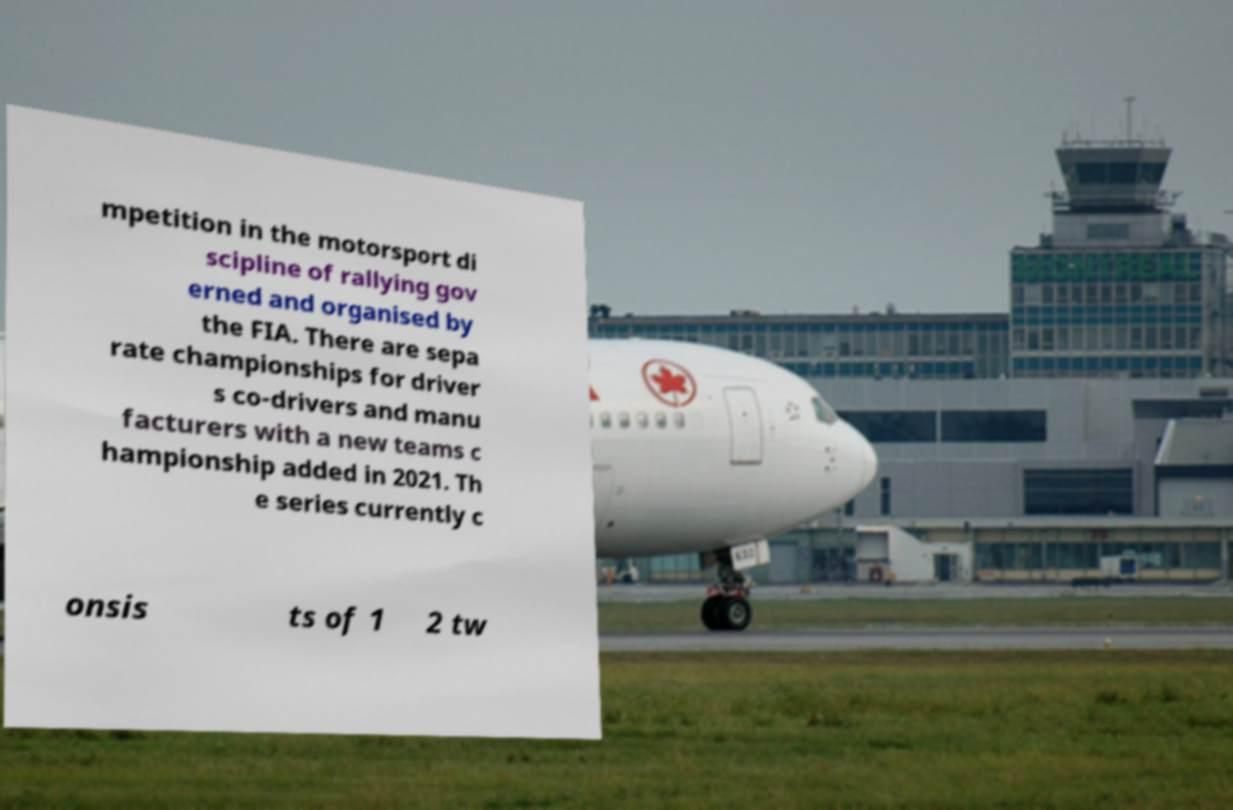Can you accurately transcribe the text from the provided image for me? mpetition in the motorsport di scipline of rallying gov erned and organised by the FIA. There are sepa rate championships for driver s co-drivers and manu facturers with a new teams c hampionship added in 2021. Th e series currently c onsis ts of 1 2 tw 